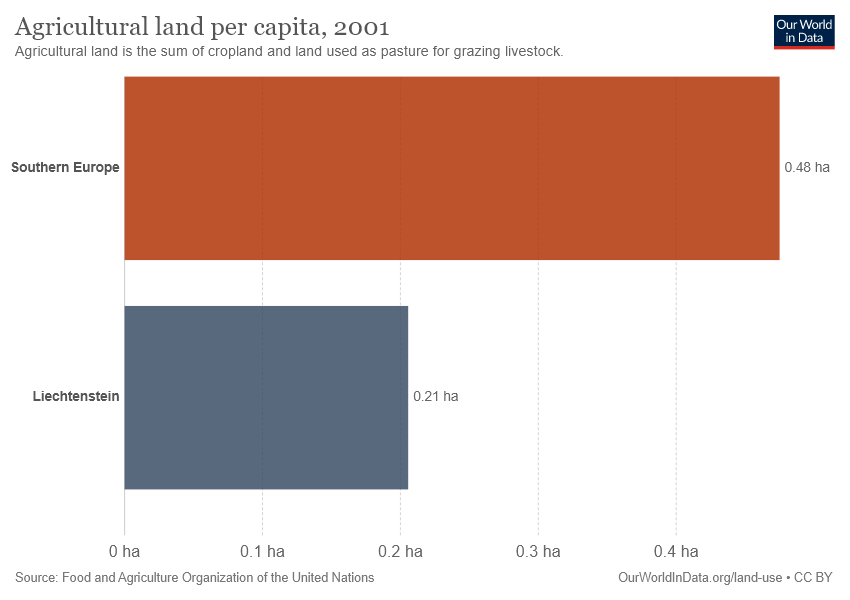Indicate a few pertinent items in this graphic. The value of agricultural land per capita in Liechtenstein is 0.21. The value of agricultural land per capita is 0.27 in the first place and 0.97 in the second place, indicating a higher value in the second place. 